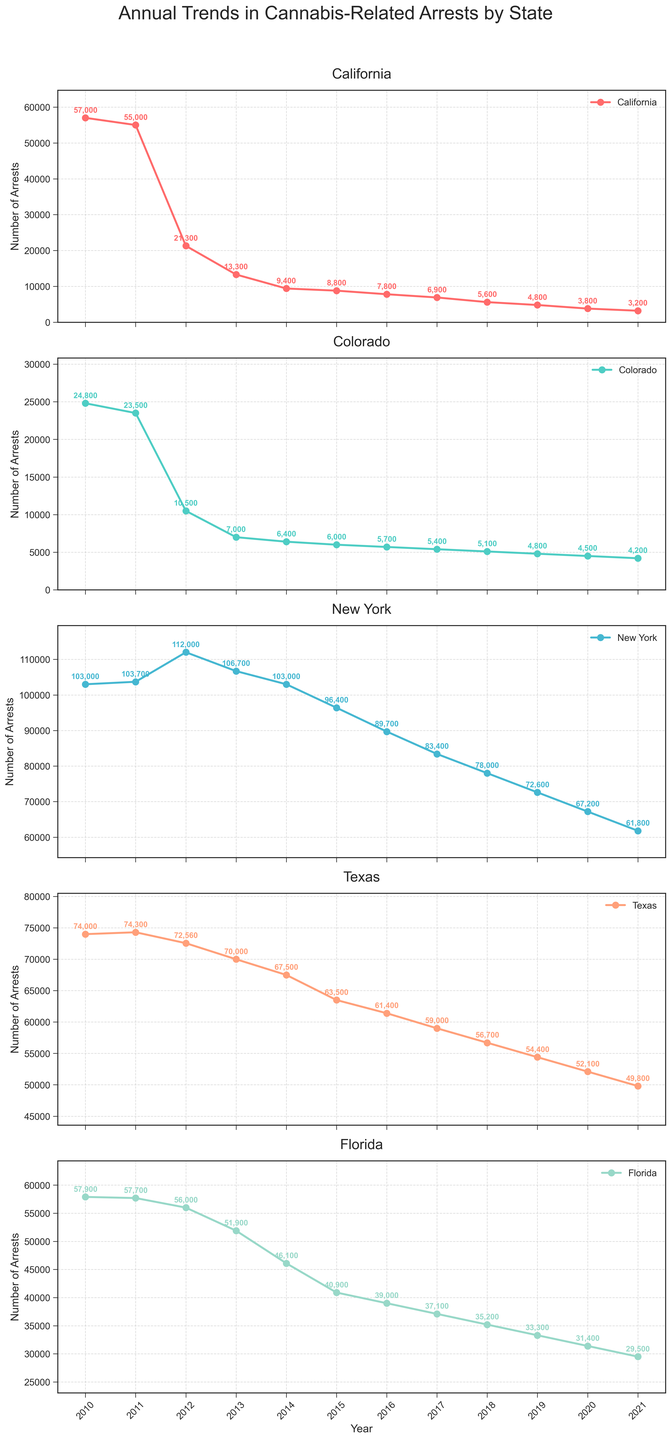Which state had the highest number of cannabis-related arrests in 2010? The plot for each state in 2010 should be compared to determine which has the highest value. New York shows the highest number of arrests in 2010.
Answer: New York By how much did cannabis-related arrests in California decrease from 2017 to 2018? To find the difference, subtract the number of arrests in 2018 from those in 2017. Specifically, it is 6,900 - 5,600.
Answer: 1,300 Which state experienced the greatest decrease in cannabis-related arrests from 2010 to 2021? To determine the greatest decrease, evaluate the difference between 2010 and 2021 for all states and identify the maximum decrease. New York has the greatest decrease, from 103,000 to 61,800.
Answer: New York On average, how many cannabis-related arrests were made per year in Colorado over the period 2010-2021? Compute the average by summing up all annual arrests for Colorado from 2010 to 2021 and then dividing by the number of years. The sum is 124,200 and the number of years is 12, so the average is 124,200 / 12.
Answer: 10,350 Did Texas or Florida have more cannabis-related arrests in 2015? Compare the numbers of arrests in Texas and Florida for the year 2015. Texas has 63,500 arrests, while Florida has 40,900.
Answer: Texas Which state's arrests remained fairly stable during the period 2011 to 2014? Examine the plots to identify which one shows minimal change in the number of arrests between 2011 and 2014. Colorado's arrests remain relatively stable during this period.
Answer: Colorado How many total cannabis-related arrests were made in 2020 across all five states? Sum the arrests for all five states in the year 2020: 3,800 + 4,500 + 67,200 + 52,100 + 31,400.
Answer: 159,000 In which year did California see the steepest year-to-year drop in cannabis-related arrests? Evaluate the year-to-year differences in California to identify the steepest drop. The greatest decrease occurs between 2011 and 2012, from 55,000 to 21,300.
Answer: 2012 What is the visual difference in the trend line between Colorado and New York from 2015 to 2021? Colorado shows a relatively stable trend with a slight decrease, while New York experiences a consistent and sharp decline.
Answer: Colorado is stable; New York declines sharply 